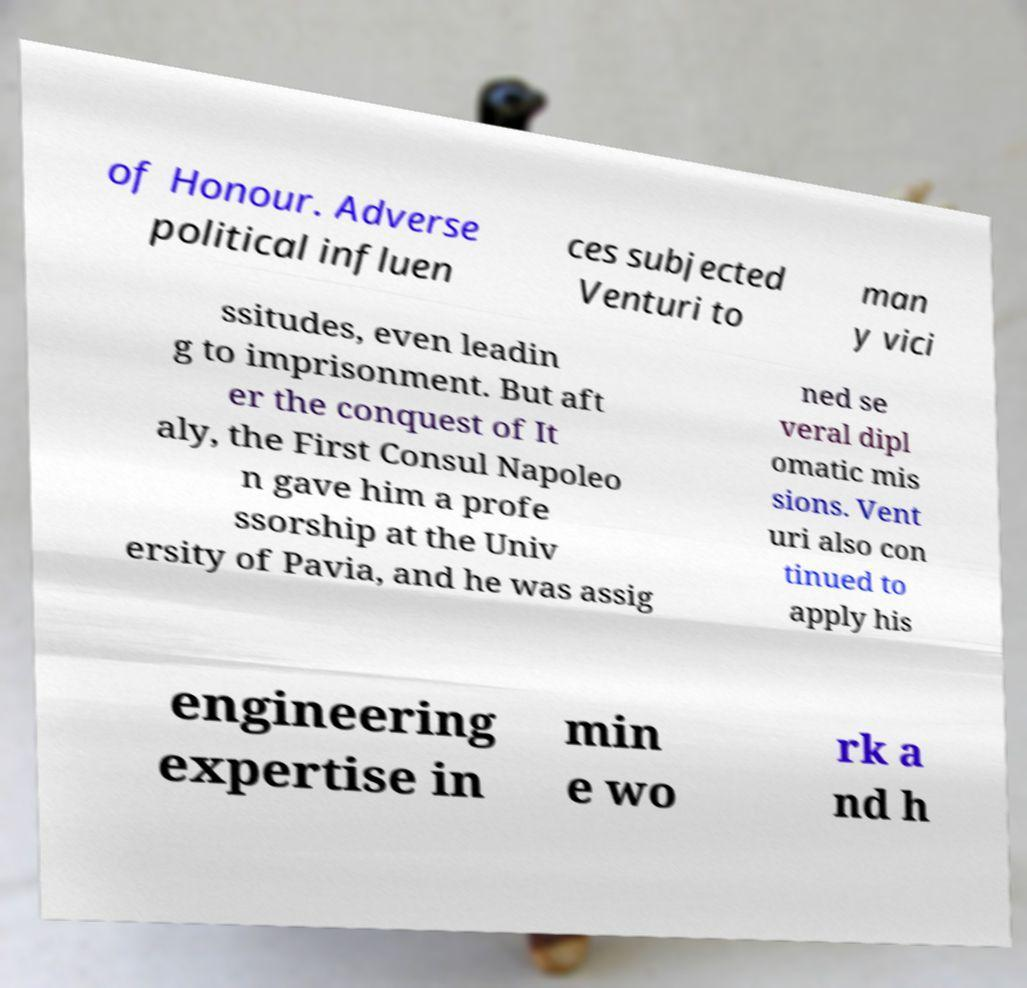For documentation purposes, I need the text within this image transcribed. Could you provide that? of Honour. Adverse political influen ces subjected Venturi to man y vici ssitudes, even leadin g to imprisonment. But aft er the conquest of It aly, the First Consul Napoleo n gave him a profe ssorship at the Univ ersity of Pavia, and he was assig ned se veral dipl omatic mis sions. Vent uri also con tinued to apply his engineering expertise in min e wo rk a nd h 